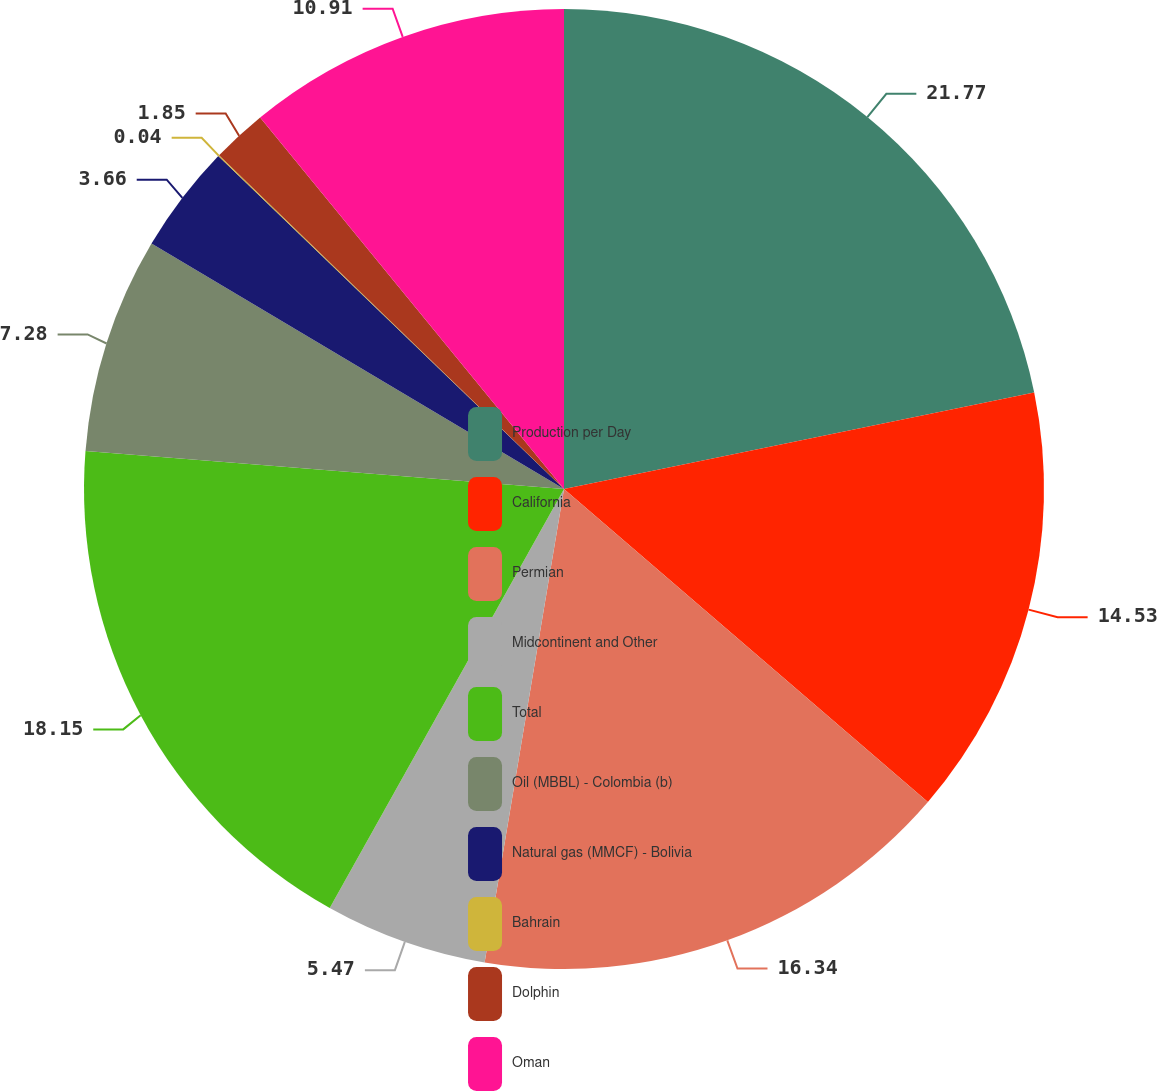Convert chart. <chart><loc_0><loc_0><loc_500><loc_500><pie_chart><fcel>Production per Day<fcel>California<fcel>Permian<fcel>Midcontinent and Other<fcel>Total<fcel>Oil (MBBL) - Colombia (b)<fcel>Natural gas (MMCF) - Bolivia<fcel>Bahrain<fcel>Dolphin<fcel>Oman<nl><fcel>21.78%<fcel>14.53%<fcel>16.34%<fcel>5.47%<fcel>18.15%<fcel>7.28%<fcel>3.66%<fcel>0.04%<fcel>1.85%<fcel>10.91%<nl></chart> 